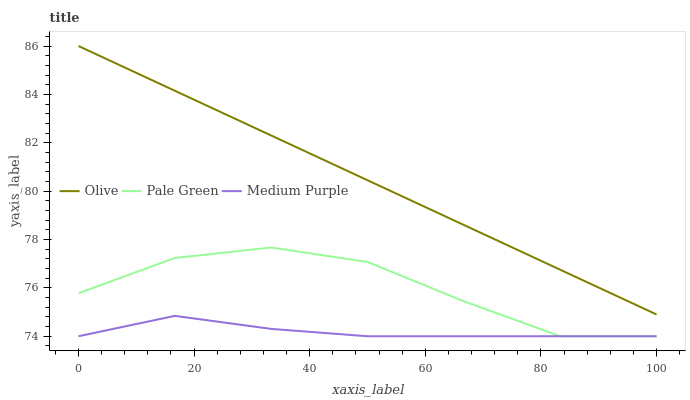Does Medium Purple have the minimum area under the curve?
Answer yes or no. Yes. Does Olive have the maximum area under the curve?
Answer yes or no. Yes. Does Pale Green have the minimum area under the curve?
Answer yes or no. No. Does Pale Green have the maximum area under the curve?
Answer yes or no. No. Is Olive the smoothest?
Answer yes or no. Yes. Is Pale Green the roughest?
Answer yes or no. Yes. Is Medium Purple the smoothest?
Answer yes or no. No. Is Medium Purple the roughest?
Answer yes or no. No. Does Pale Green have the highest value?
Answer yes or no. No. Is Medium Purple less than Olive?
Answer yes or no. Yes. Is Olive greater than Medium Purple?
Answer yes or no. Yes. Does Medium Purple intersect Olive?
Answer yes or no. No. 